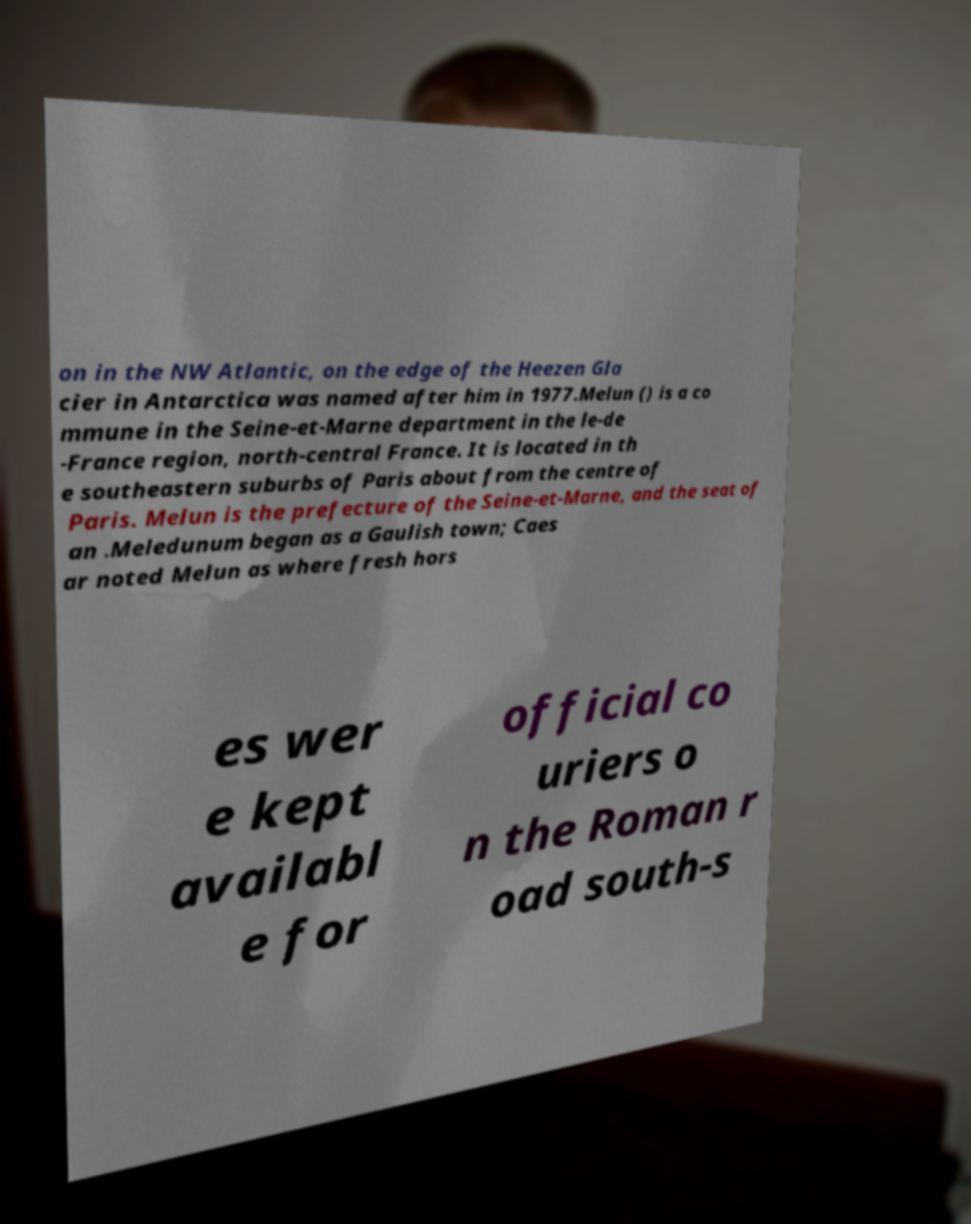Please read and relay the text visible in this image. What does it say? on in the NW Atlantic, on the edge of the Heezen Gla cier in Antarctica was named after him in 1977.Melun () is a co mmune in the Seine-et-Marne department in the le-de -France region, north-central France. It is located in th e southeastern suburbs of Paris about from the centre of Paris. Melun is the prefecture of the Seine-et-Marne, and the seat of an .Meledunum began as a Gaulish town; Caes ar noted Melun as where fresh hors es wer e kept availabl e for official co uriers o n the Roman r oad south-s 